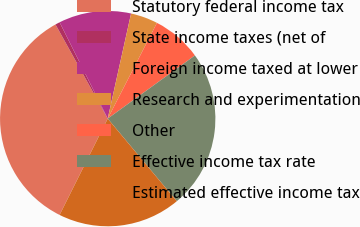Convert chart. <chart><loc_0><loc_0><loc_500><loc_500><pie_chart><fcel>Statutory federal income tax<fcel>State income taxes (net of<fcel>Foreign income taxed at lower<fcel>Research and experimentation<fcel>Other<fcel>Effective income tax rate<fcel>Estimated effective income tax<nl><fcel>34.56%<fcel>0.69%<fcel>10.85%<fcel>4.08%<fcel>7.46%<fcel>23.89%<fcel>18.46%<nl></chart> 